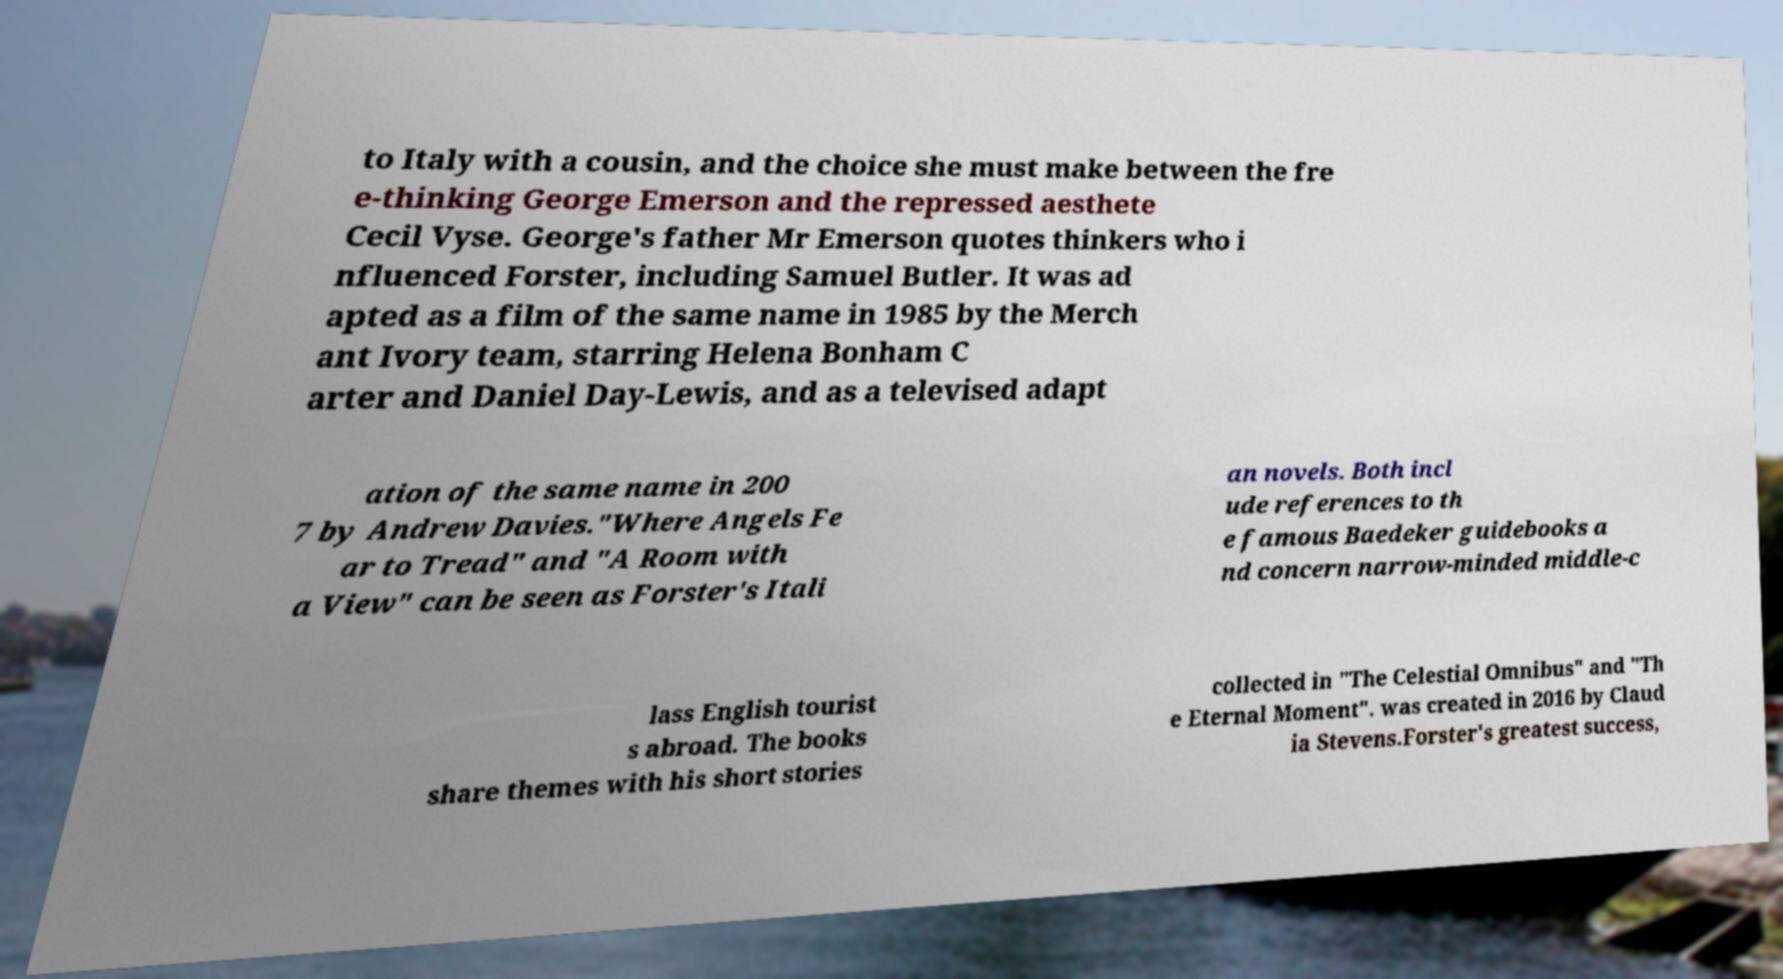Can you accurately transcribe the text from the provided image for me? to Italy with a cousin, and the choice she must make between the fre e-thinking George Emerson and the repressed aesthete Cecil Vyse. George's father Mr Emerson quotes thinkers who i nfluenced Forster, including Samuel Butler. It was ad apted as a film of the same name in 1985 by the Merch ant Ivory team, starring Helena Bonham C arter and Daniel Day-Lewis, and as a televised adapt ation of the same name in 200 7 by Andrew Davies."Where Angels Fe ar to Tread" and "A Room with a View" can be seen as Forster's Itali an novels. Both incl ude references to th e famous Baedeker guidebooks a nd concern narrow-minded middle-c lass English tourist s abroad. The books share themes with his short stories collected in "The Celestial Omnibus" and "Th e Eternal Moment". was created in 2016 by Claud ia Stevens.Forster's greatest success, 